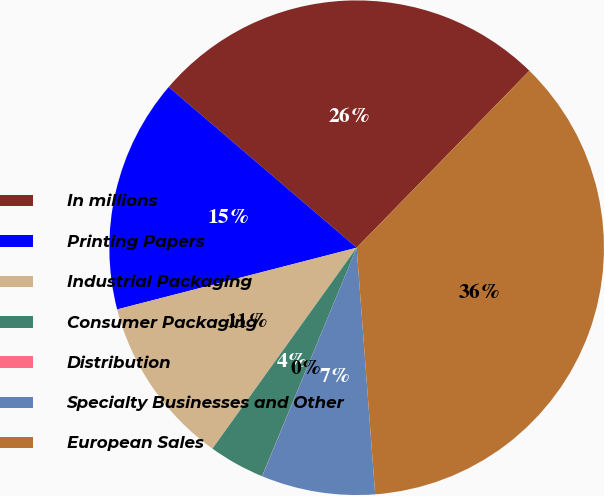Convert chart. <chart><loc_0><loc_0><loc_500><loc_500><pie_chart><fcel>In millions<fcel>Printing Papers<fcel>Industrial Packaging<fcel>Consumer Packaging<fcel>Distribution<fcel>Specialty Businesses and Other<fcel>European Sales<nl><fcel>26.05%<fcel>15.27%<fcel>11.08%<fcel>3.66%<fcel>0.01%<fcel>7.43%<fcel>36.5%<nl></chart> 